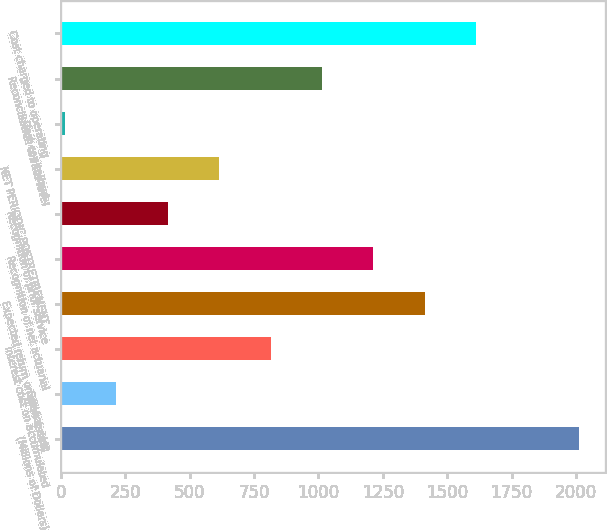Convert chart to OTSL. <chart><loc_0><loc_0><loc_500><loc_500><bar_chart><fcel>(Millions of Dollars)<fcel>Service cost<fcel>Interest cost on accumulated<fcel>Expected return on plan assets<fcel>Recognition of net actuarial<fcel>Recognition of prior service<fcel>NET PERIODIC POSTRETIREMENT<fcel>Cost capitalized<fcel>Reconciliation to rate level<fcel>Cost charged to operating<nl><fcel>2013<fcel>214.8<fcel>814.2<fcel>1413.6<fcel>1213.8<fcel>414.6<fcel>614.4<fcel>15<fcel>1014<fcel>1613.4<nl></chart> 